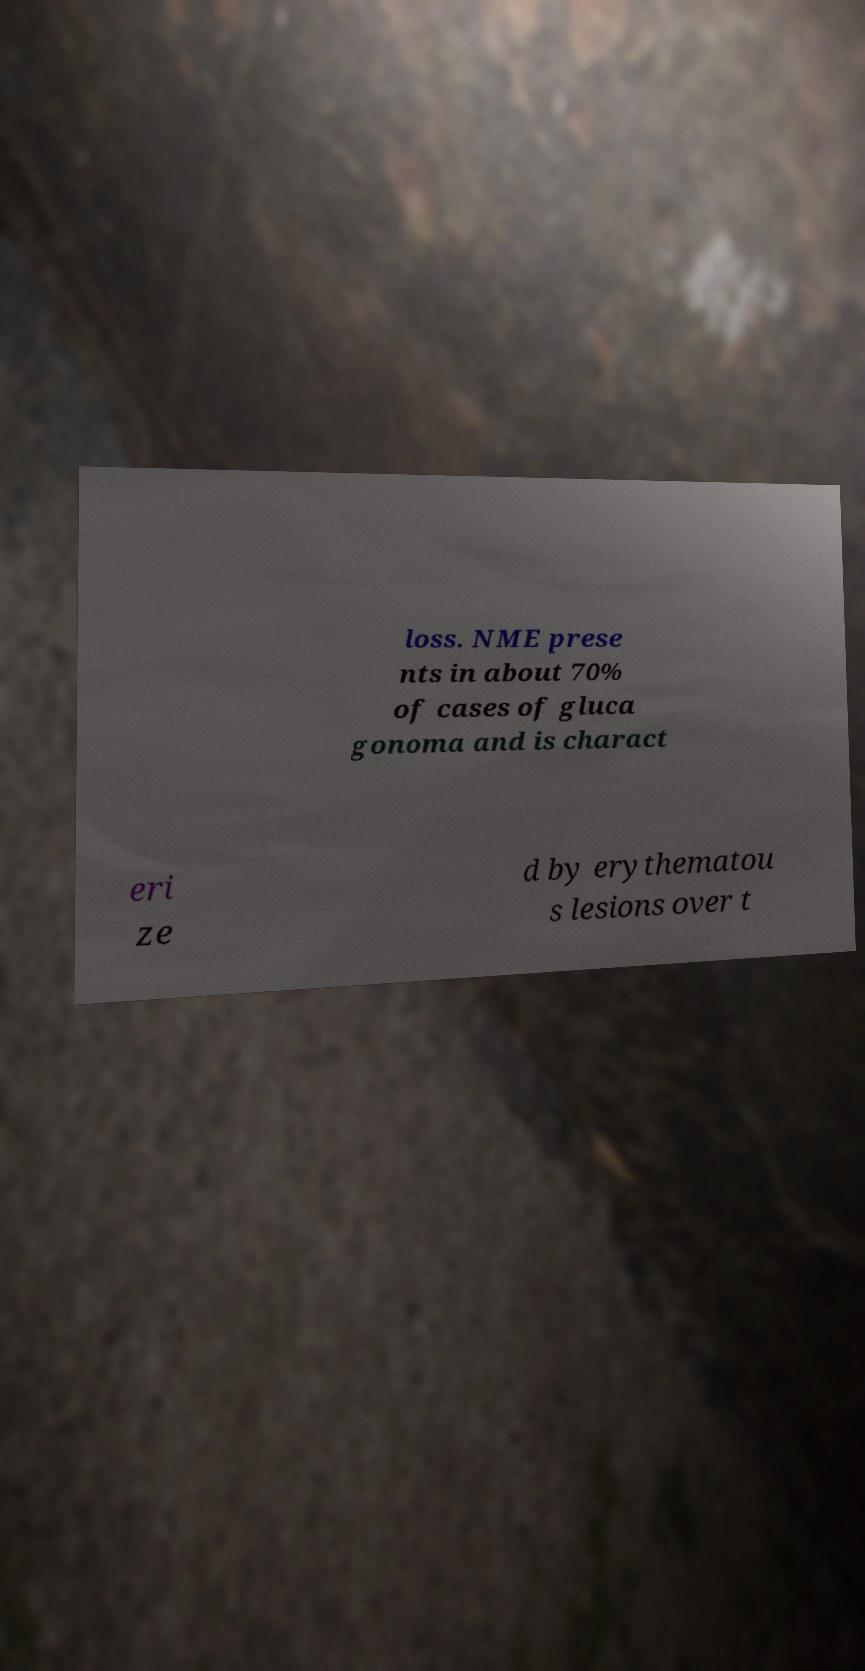What messages or text are displayed in this image? I need them in a readable, typed format. loss. NME prese nts in about 70% of cases of gluca gonoma and is charact eri ze d by erythematou s lesions over t 